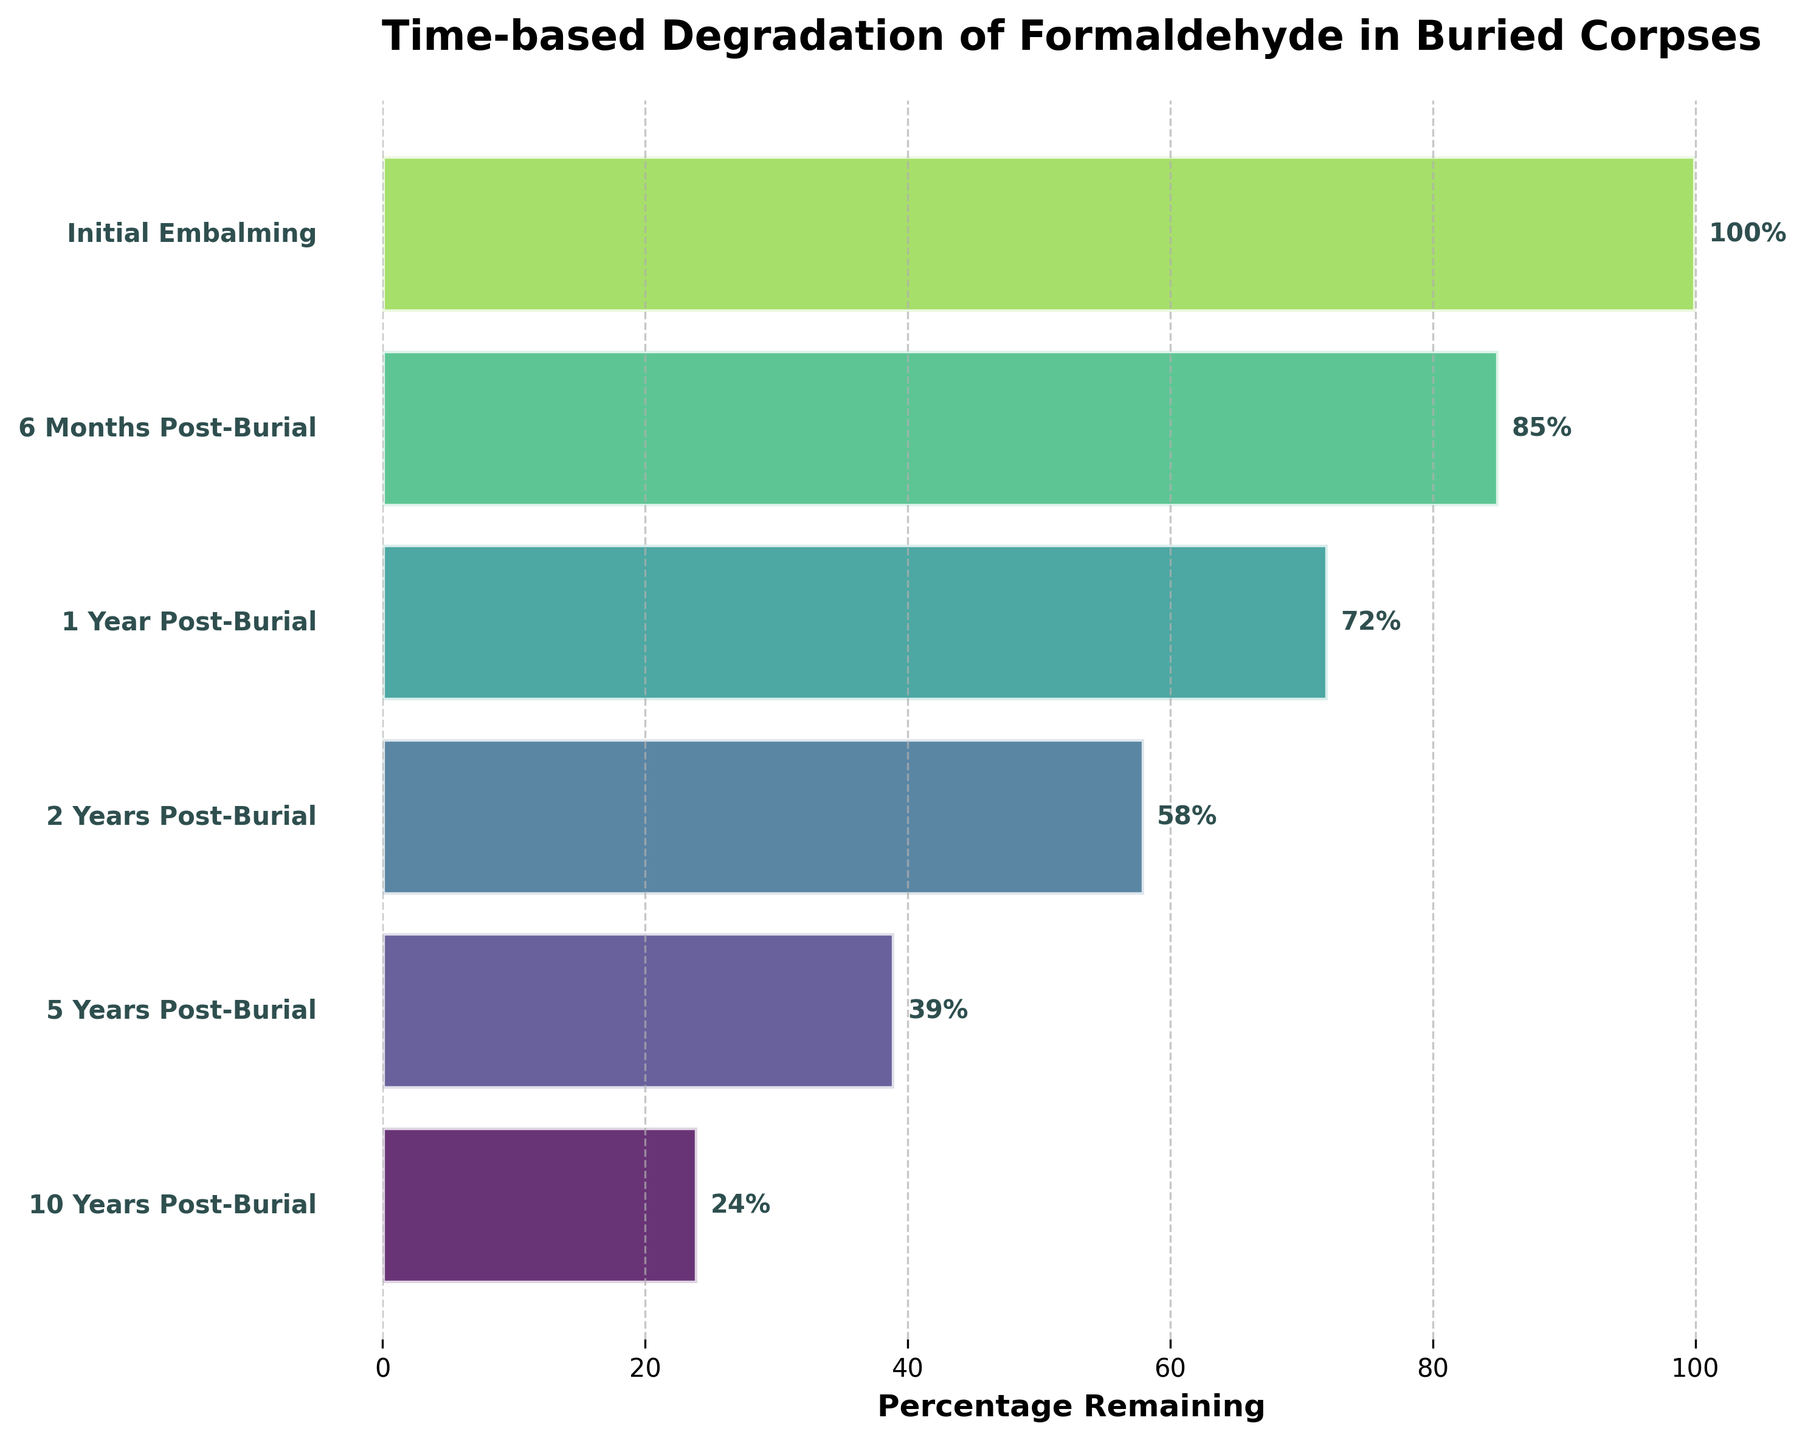What is the title of the chart? The chart has a title at the top, which reads "Time-based Degradation of Formaldehyde in Buried Corpses". This title gives an overview of what the chart illustrates.
Answer: Time-based Degradation of Formaldehyde in Buried Corpses What does the x-axis represent? The x-axis is labeled "Percentage Remaining". It represents the remaining percentage of formaldehyde in the buried corpses over time.
Answer: Percentage Remaining How many stages are shown in the funnel chart? There are six stages represented in the chart: "Initial Embalming", "6 Months Post-Burial", "1 Year Post-Burial", "2 Years Post-Burial", "5 Years Post-Burial", and "10 Years Post-Burial".
Answer: 6 What is the percentage of formaldehyde remaining after 5 years? According to the funnel chart, the bar for "5 Years Post-Burial" shows a percentage of 39% remaining.
Answer: 39% Which time period shows the largest decrease in percentage remaining of formaldehyde? By looking at the differences between each adjacent stage, the largest decrease occurs between "2 Years Post-Burial" (58%) and "5 Years Post-Burial" (39%), resulting in a decrease of 19%.
Answer: Between "2 Years Post-Burial" and "5 Years Post-Burial" What is the difference in the percentage of formaldehyde remaining between 6 months and 2 years? At 6 months, the formaldehyde percentage is 85%, and at 2 years, it is 58%. The difference is: 85% - 58% = 27%.
Answer: 27% What percentage of formaldehyde remains after 10 years? The funnel segment labeled "10 Years Post-Burial" indicates a remaining percentage of 24%.
Answer: 24% Compare the percentages of formaldehyde remaining between 1 year and 10 years. Which one is higher? From the chart, after 1 year, 72% of formaldehyde remains, and after 10 years, 24% remains. Therefore, 1 year has a higher percentage of formaldehyde remaining.
Answer: 1 Year Post-Burial What is the average percentage of formaldehyde remaining from 1 year to 10 years? From 1 year to 10 years, the percentages are 72%, 58%, 39%, and 24%. The average is calculated as: (72 + 58 + 39 + 24) / 4 = 193 / 4 = 48.25%.
Answer: 48.25% What trend does the funnel chart indicate about the formaldehyde percentage over time? The chart indicates a decreasing trend in the percentage of formaldehyde remaining over time, starting from 100% at initial embalming to 24% after 10 years.
Answer: Decreasing trend 